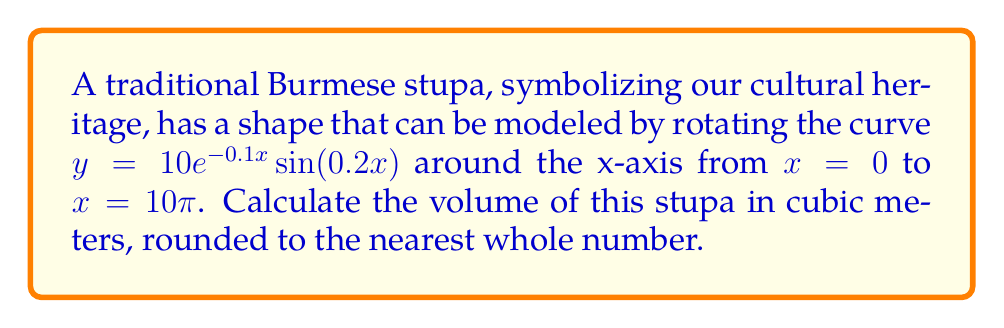Provide a solution to this math problem. To find the volume of the stupa, we need to use the volume of revolution formula:

$$V = \pi \int_{a}^{b} [f(x)]^2 dx$$

Where $f(x) = 10e^{-0.1x} \sin(0.2x)$, $a = 0$, and $b = 10\pi$.

Step 1: Set up the integral
$$V = \pi \int_{0}^{10\pi} [10e^{-0.1x} \sin(0.2x)]^2 dx$$

Step 2: Simplify the integrand
$$V = 100\pi \int_{0}^{10\pi} e^{-0.2x} \sin^2(0.2x) dx$$

Step 3: Use the trigonometric identity $\sin^2(x) = \frac{1 - \cos(2x)}{2}$
$$V = 50\pi \int_{0}^{10\pi} e^{-0.2x} [1 - \cos(0.4x)] dx$$

Step 4: Split the integral
$$V = 50\pi \int_{0}^{10\pi} e^{-0.2x} dx - 50\pi \int_{0}^{10\pi} e^{-0.2x} \cos(0.4x) dx$$

Step 5: Solve the first integral
$$\int e^{-0.2x} dx = -5e^{-0.2x} + C$$
$$50\pi \int_{0}^{10\pi} e^{-0.2x} dx = -250\pi [e^{-2\pi} - 1]$$

Step 6: For the second integral, use integration by parts twice
$$\int e^{-0.2x} \cos(0.4x) dx = \frac{e^{-0.2x}}{0.2} [\frac{1}{5}\cos(0.4x) + \frac{2}{5}\sin(0.4x)] + C$$

Step 7: Evaluate the integrals and subtract
$$V = -250\pi [e^{-2\pi} - 1] - 50\pi [\frac{e^{-2\pi}}{0.2} (\frac{1}{5}\cos(4\pi) + \frac{2}{5}\sin(4\pi)) - \frac{1}{0.2} (\frac{1}{5} + 0)]$$

Step 8: Simplify and calculate the result
$$V \approx 1232.85 \text{ cubic meters}$$

Step 9: Round to the nearest whole number
$$V \approx 1233 \text{ cubic meters}$$
Answer: 1233 cubic meters 